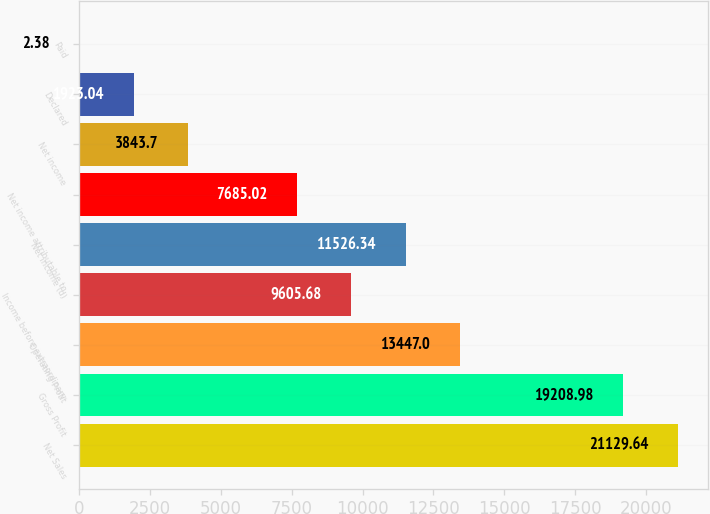<chart> <loc_0><loc_0><loc_500><loc_500><bar_chart><fcel>Net Sales<fcel>Gross Profit<fcel>Operating Profit<fcel>Income before extraordinary<fcel>Net income (d)<fcel>Net income attributable to<fcel>Net income<fcel>Declared<fcel>Paid<nl><fcel>21129.6<fcel>19209<fcel>13447<fcel>9605.68<fcel>11526.3<fcel>7685.02<fcel>3843.7<fcel>1923.04<fcel>2.38<nl></chart> 